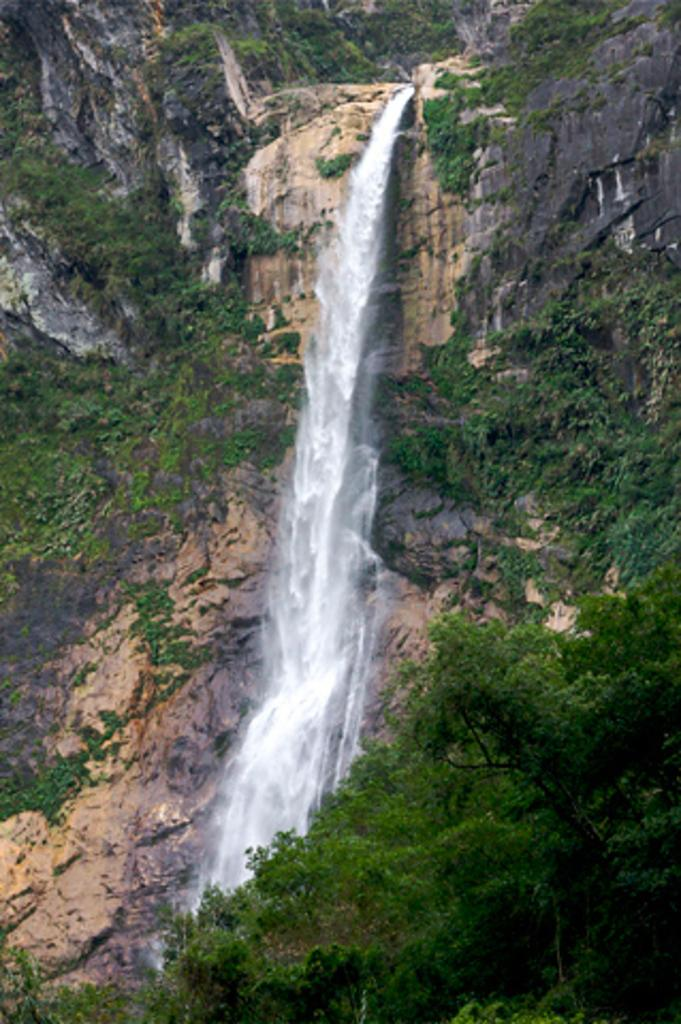What types of vegetation are at the bottom of the image? There are plants and trees at the bottom of the image. What natural feature can be seen in the background of the image? There is a waterfall in the background of the image. Where is the waterfall coming from? The waterfall is coming from a mountain. Are there any trees on the mountain? Yes, trees are present on the mountain. What size is the shirt worn by the tree on the mountain? There is no shirt present in the image, as trees do not wear clothing. 